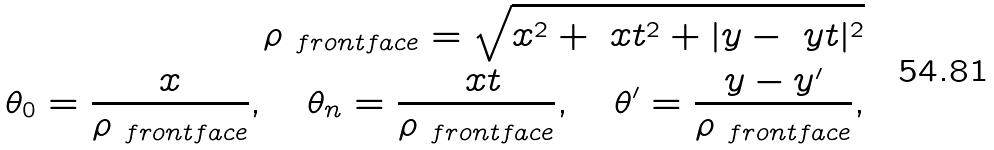<formula> <loc_0><loc_0><loc_500><loc_500>\rho _ { \ f r o n t f a c e } = \sqrt { x ^ { 2 } + \ x t ^ { 2 } + | y - \ y t | ^ { 2 } } \\ \theta _ { 0 } = \frac { x } { \rho _ { \ f r o n t f a c e } } , \quad \theta _ { n } = \frac { \ x t } { \rho _ { \ f r o n t f a c e } } , \quad \theta ^ { \prime } = \frac { y - y ^ { \prime } } { \rho _ { \ f r o n t f a c e } } ,</formula> 